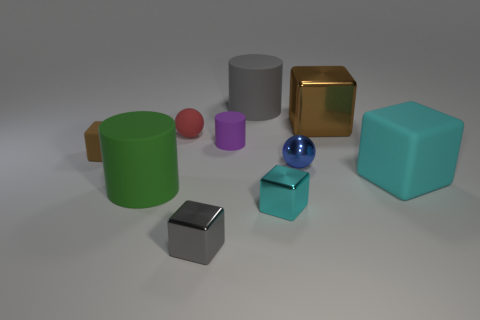Subtract all large green cylinders. How many cylinders are left? 2 Subtract all brown blocks. How many blocks are left? 3 Subtract 0 cyan cylinders. How many objects are left? 10 Subtract all cylinders. How many objects are left? 7 Subtract 5 blocks. How many blocks are left? 0 Subtract all blue balls. Subtract all gray cylinders. How many balls are left? 1 Subtract all yellow spheres. How many green cylinders are left? 1 Subtract all blue things. Subtract all purple rubber cylinders. How many objects are left? 8 Add 9 small red balls. How many small red balls are left? 10 Add 2 big gray cylinders. How many big gray cylinders exist? 3 